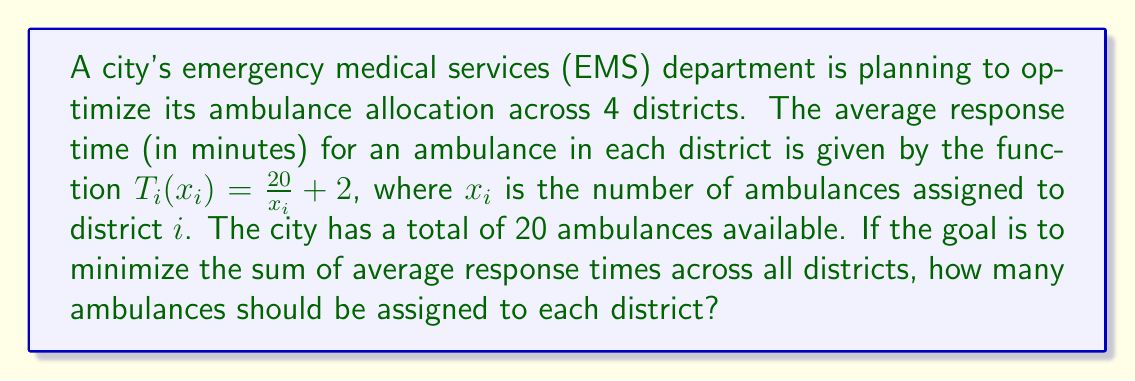Could you help me with this problem? To solve this problem, we need to use the method of Lagrange multipliers, as we're dealing with a constrained optimization problem.

1) Let's define our objective function:
   $$f(x_1, x_2, x_3, x_4) = \sum_{i=1}^4 T_i(x_i) = \sum_{i=1}^4 (\frac{20}{x_i} + 2)$$

2) Our constraint is:
   $$g(x_1, x_2, x_3, x_4) = x_1 + x_2 + x_3 + x_4 - 20 = 0$$

3) We form the Lagrangian:
   $$L(x_1, x_2, x_3, x_4, \lambda) = f(x_1, x_2, x_3, x_4) - \lambda g(x_1, x_2, x_3, x_4)$$

4) We set the partial derivatives of $L$ with respect to each variable equal to zero:
   $$\frac{\partial L}{\partial x_i} = -\frac{20}{x_i^2} - \lambda = 0 \text{ for } i = 1, 2, 3, 4$$
   $$\frac{\partial L}{\partial \lambda} = x_1 + x_2 + x_3 + x_4 - 20 = 0$$

5) From the first equation, we can deduce that:
   $$x_i = \sqrt{\frac{20}{\lambda}} \text{ for } i = 1, 2, 3, 4$$

6) Substituting this into the constraint equation:
   $$4\sqrt{\frac{20}{\lambda}} = 20$$

7) Solving for $\lambda$:
   $$\lambda = \frac{16}{25} = 0.64$$

8) Finally, we can calculate $x_i$:
   $$x_i = \sqrt{\frac{20}{0.64}} = 5 \text{ for } i = 1, 2, 3, 4$$

Therefore, the optimal allocation is 5 ambulances to each district.
Answer: The optimal allocation is 5 ambulances to each of the 4 districts. 